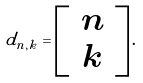Convert formula to latex. <formula><loc_0><loc_0><loc_500><loc_500>d _ { n , k } = \left [ \, \begin{array} { c } n \\ k \end{array} \, \right ] .</formula> 